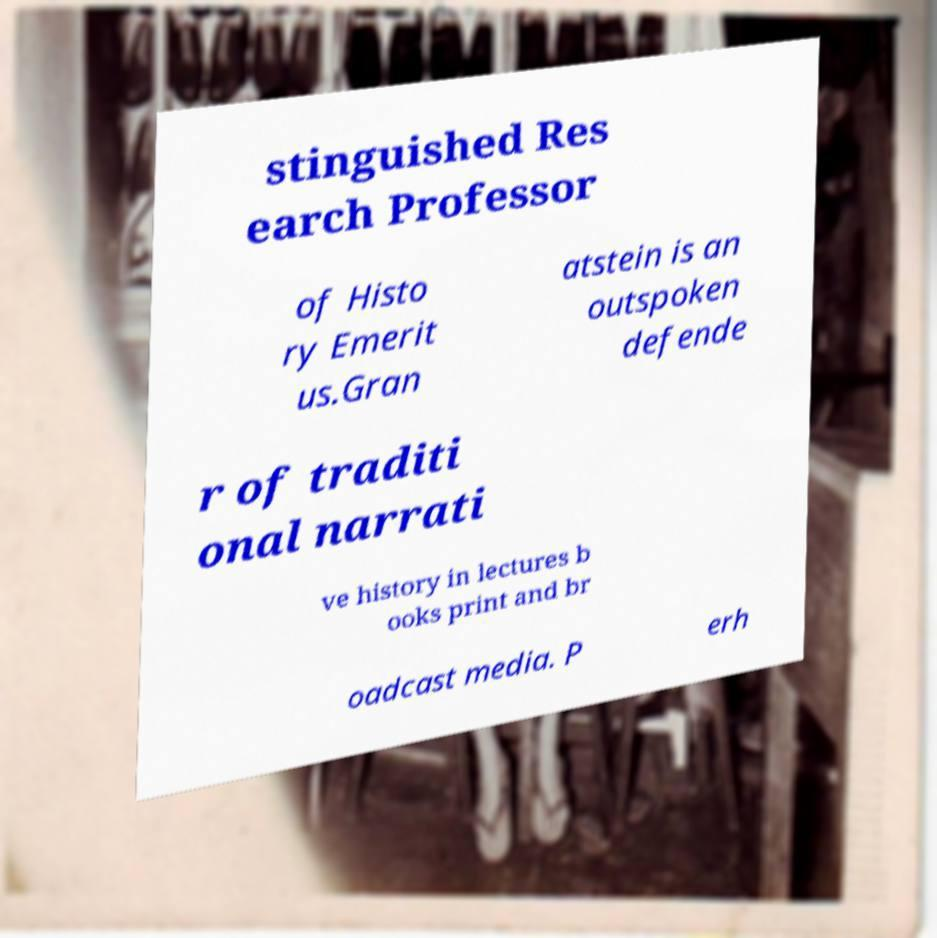There's text embedded in this image that I need extracted. Can you transcribe it verbatim? stinguished Res earch Professor of Histo ry Emerit us.Gran atstein is an outspoken defende r of traditi onal narrati ve history in lectures b ooks print and br oadcast media. P erh 